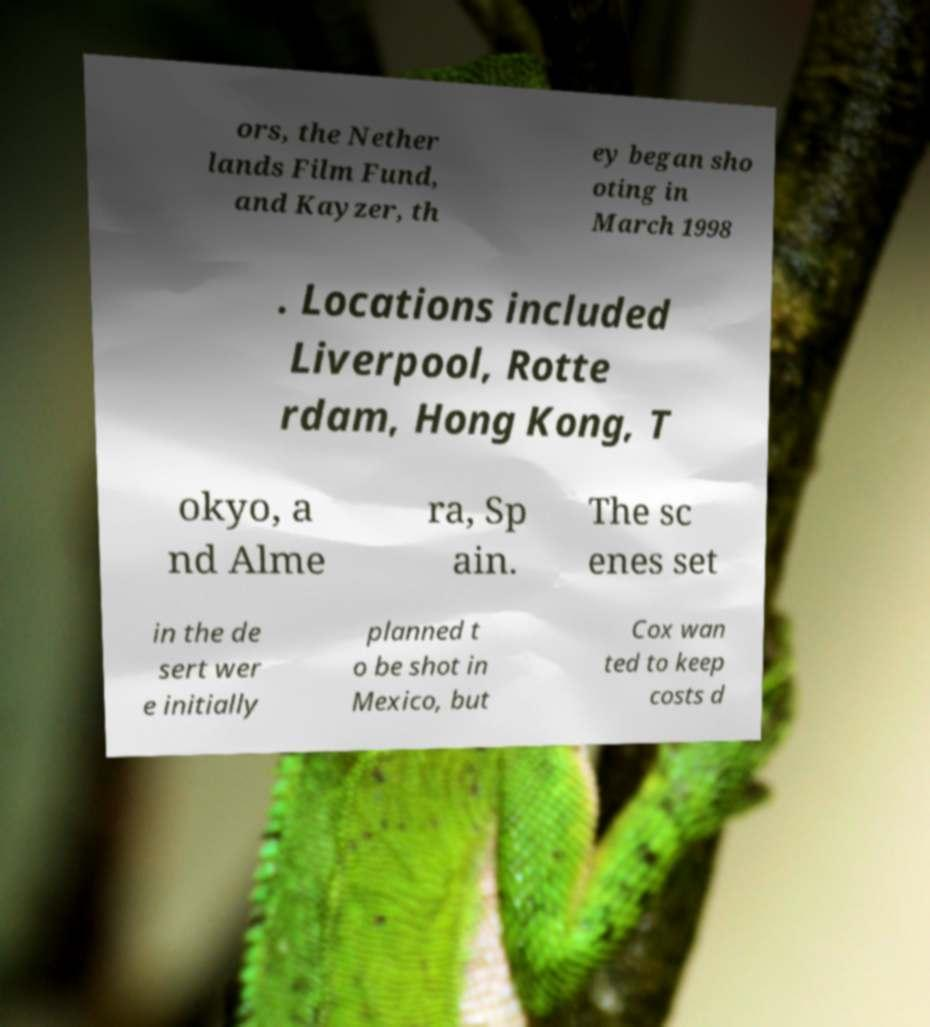Could you extract and type out the text from this image? ors, the Nether lands Film Fund, and Kayzer, th ey began sho oting in March 1998 . Locations included Liverpool, Rotte rdam, Hong Kong, T okyo, a nd Alme ra, Sp ain. The sc enes set in the de sert wer e initially planned t o be shot in Mexico, but Cox wan ted to keep costs d 